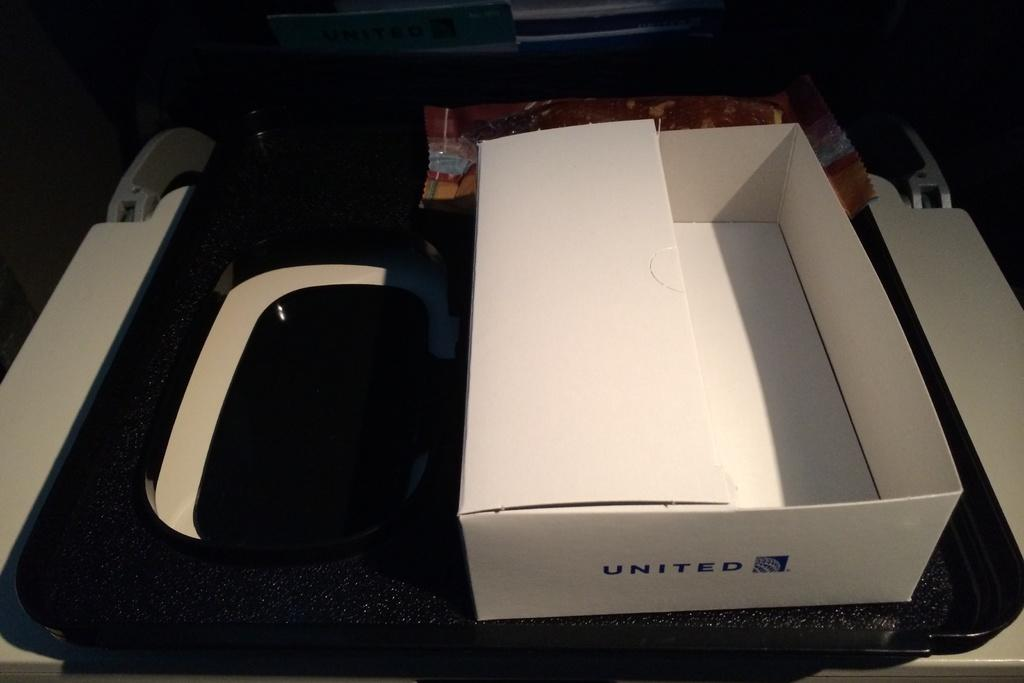<image>
Relay a brief, clear account of the picture shown. An empty box with United printed on the side sits on top of a printer. 